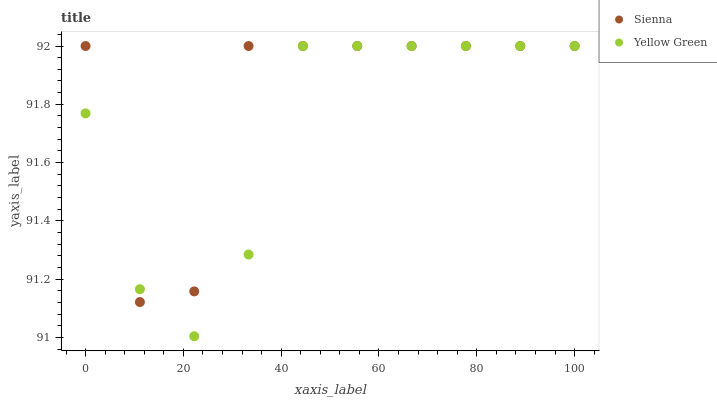Does Yellow Green have the minimum area under the curve?
Answer yes or no. Yes. Does Sienna have the maximum area under the curve?
Answer yes or no. Yes. Does Yellow Green have the maximum area under the curve?
Answer yes or no. No. Is Yellow Green the smoothest?
Answer yes or no. Yes. Is Sienna the roughest?
Answer yes or no. Yes. Is Yellow Green the roughest?
Answer yes or no. No. Does Yellow Green have the lowest value?
Answer yes or no. Yes. Does Yellow Green have the highest value?
Answer yes or no. Yes. Does Sienna intersect Yellow Green?
Answer yes or no. Yes. Is Sienna less than Yellow Green?
Answer yes or no. No. Is Sienna greater than Yellow Green?
Answer yes or no. No. 